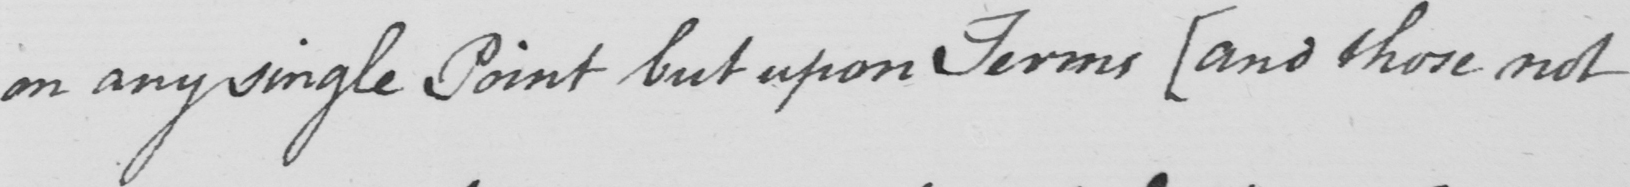Can you read and transcribe this handwriting? on any single Point but upon Terms [and those not 